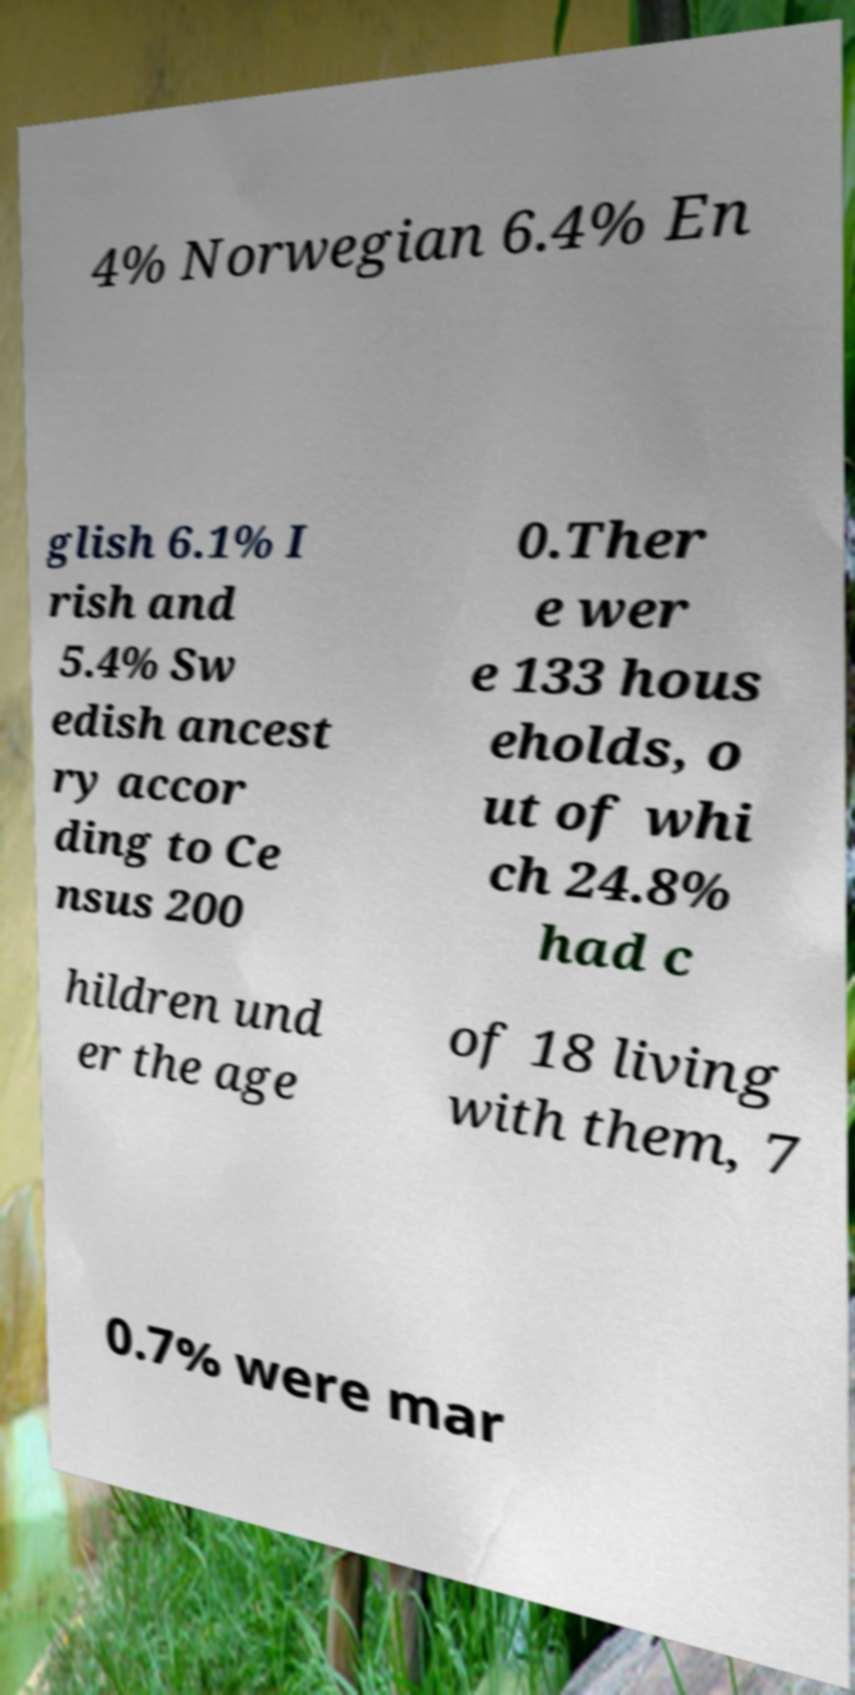Could you extract and type out the text from this image? 4% Norwegian 6.4% En glish 6.1% I rish and 5.4% Sw edish ancest ry accor ding to Ce nsus 200 0.Ther e wer e 133 hous eholds, o ut of whi ch 24.8% had c hildren und er the age of 18 living with them, 7 0.7% were mar 